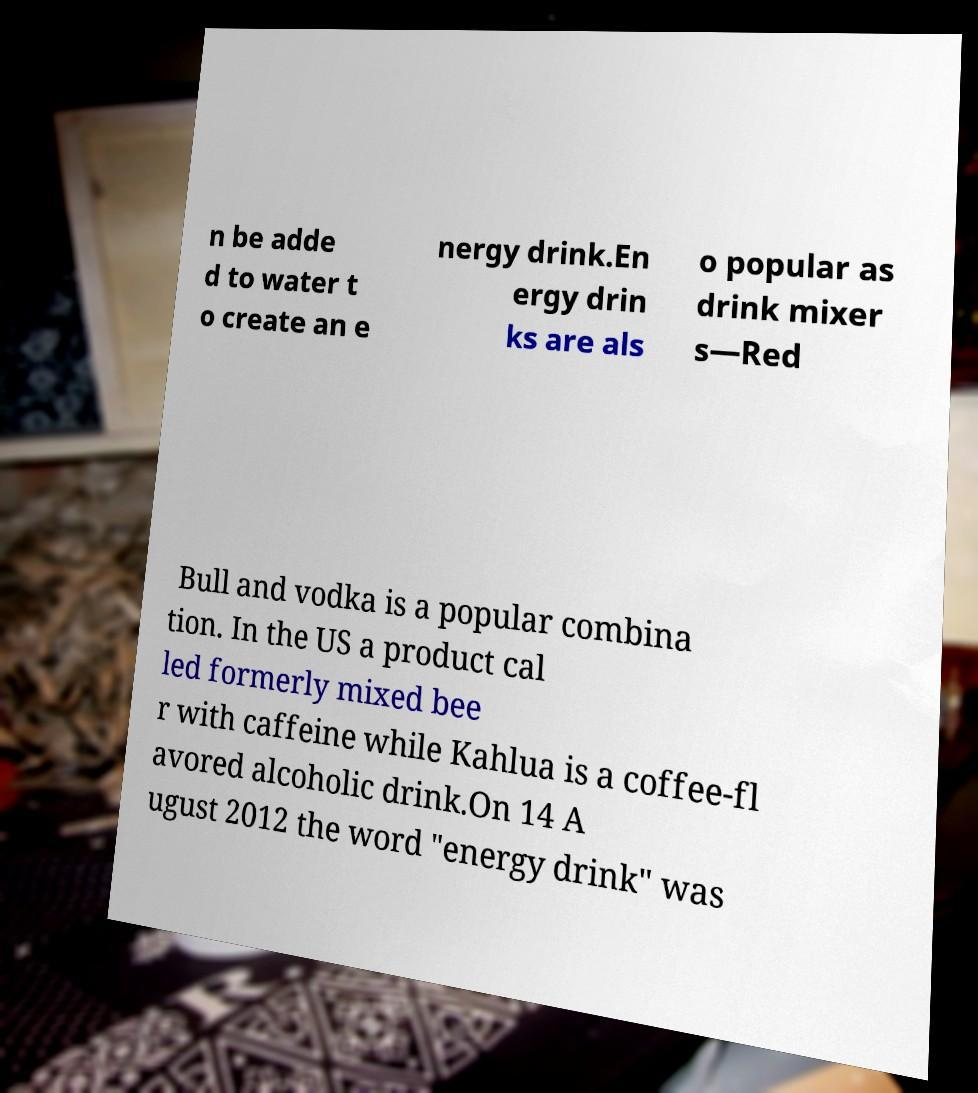Please identify and transcribe the text found in this image. n be adde d to water t o create an e nergy drink.En ergy drin ks are als o popular as drink mixer s—Red Bull and vodka is a popular combina tion. In the US a product cal led formerly mixed bee r with caffeine while Kahlua is a coffee-fl avored alcoholic drink.On 14 A ugust 2012 the word "energy drink" was 